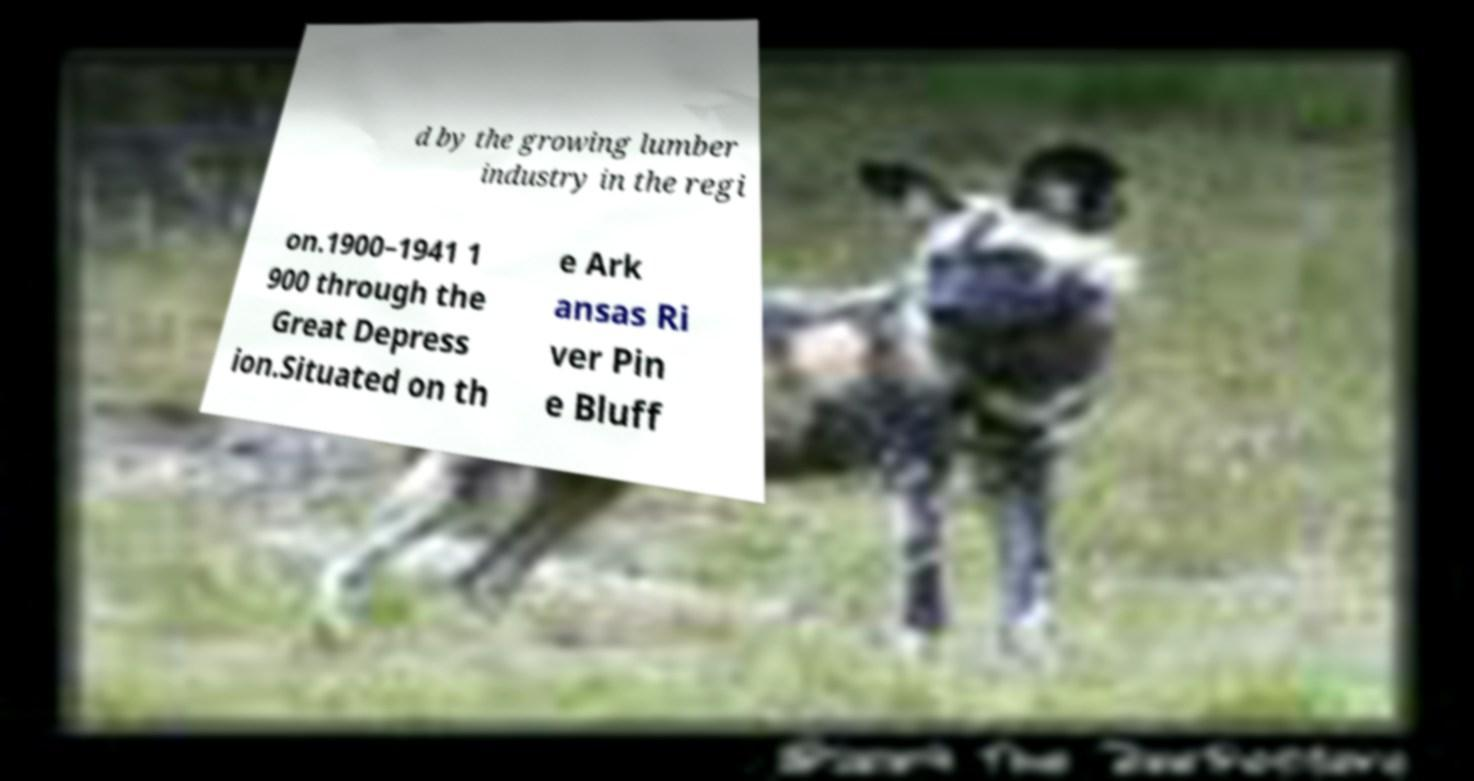Could you extract and type out the text from this image? d by the growing lumber industry in the regi on.1900–1941 1 900 through the Great Depress ion.Situated on th e Ark ansas Ri ver Pin e Bluff 